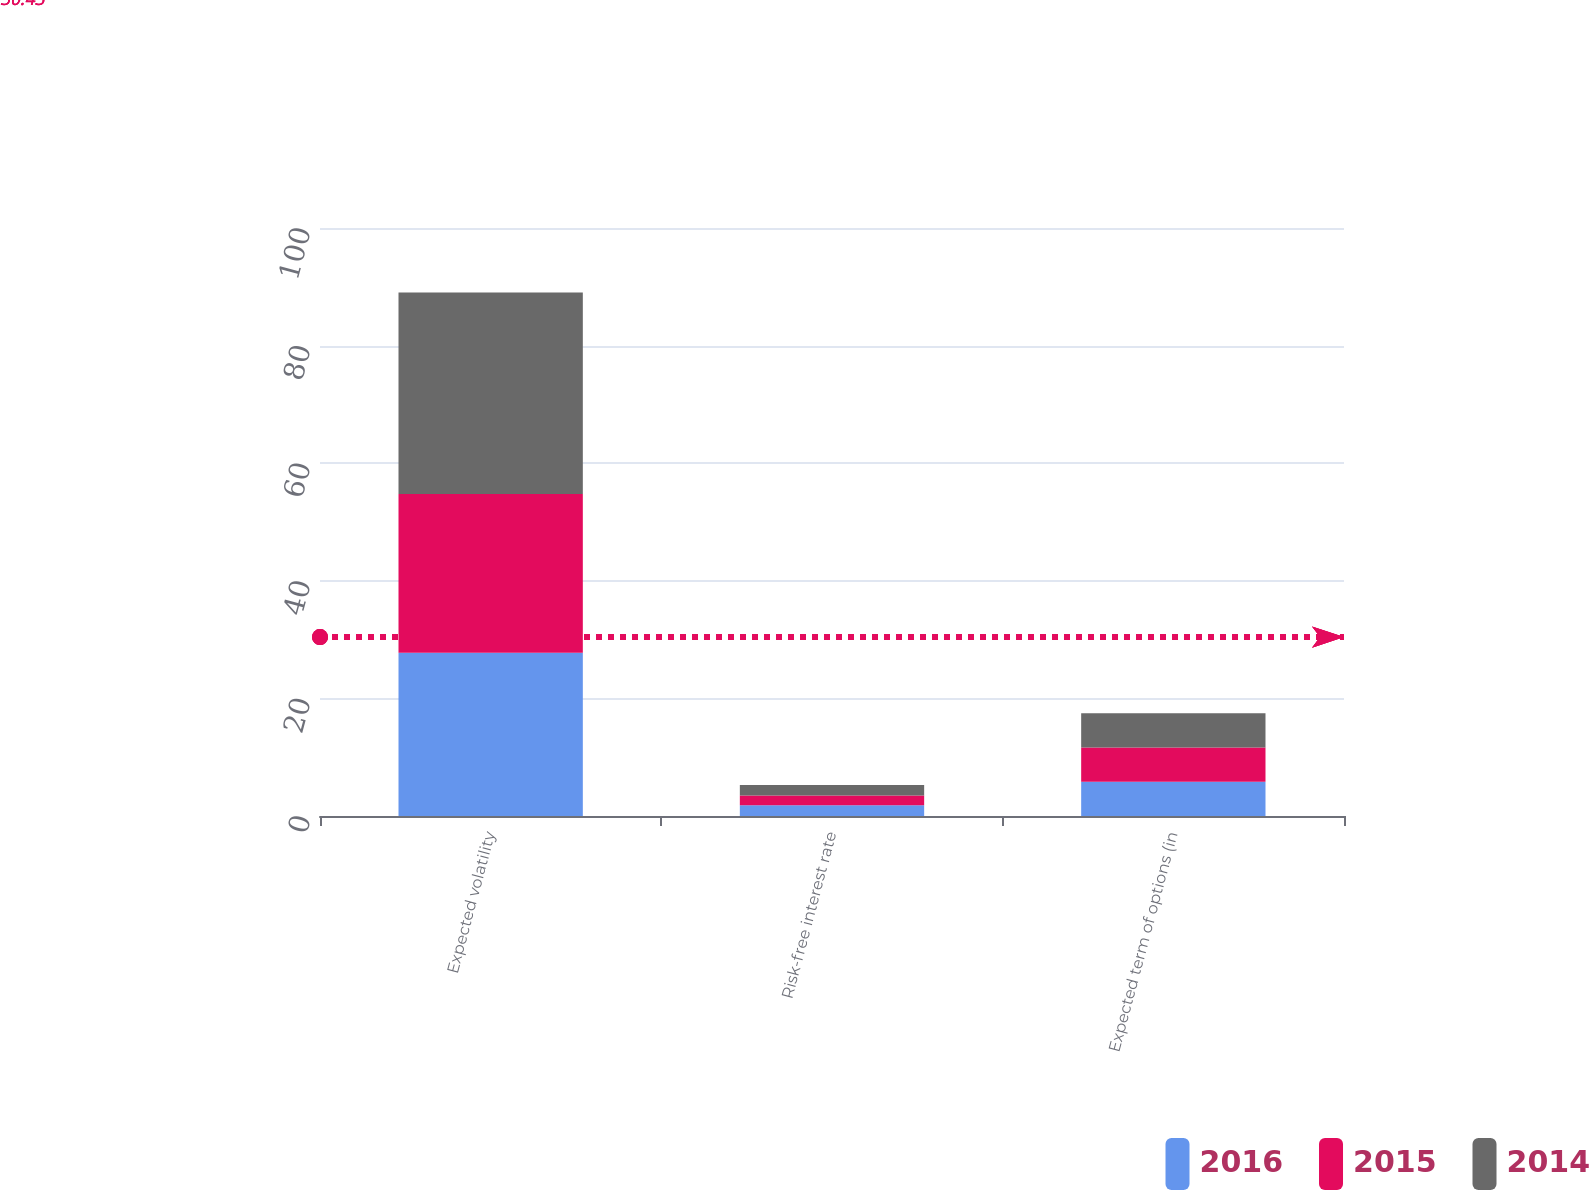<chart> <loc_0><loc_0><loc_500><loc_500><stacked_bar_chart><ecel><fcel>Expected volatility<fcel>Risk-free interest rate<fcel>Expected term of options (in<nl><fcel>2016<fcel>27.77<fcel>1.82<fcel>5.82<nl><fcel>2015<fcel>27<fcel>1.67<fcel>5.82<nl><fcel>2014<fcel>34.25<fcel>1.79<fcel>5.82<nl></chart> 